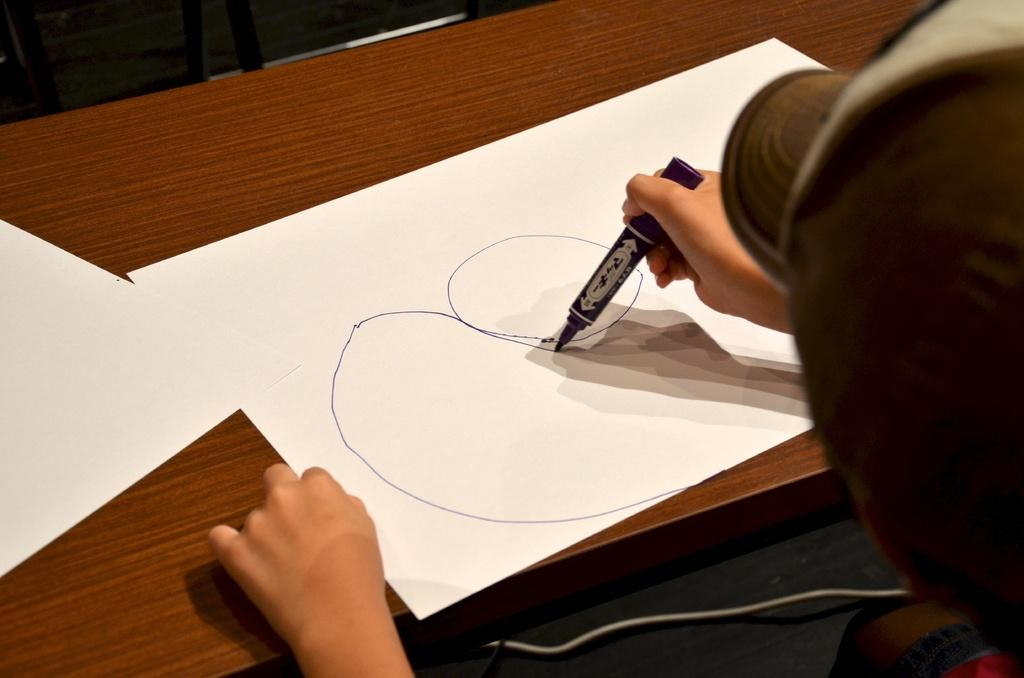What is present on the table in the image? There is a paper on the table. What is the person doing in the image? A person is drawing on the paper. Can you describe the table in the image? The table is a flat surface where the paper is placed. What scent can be detected from the drawing in the image? There is no information about the scent of the drawing in the image. The focus is on the visual aspects of the drawing and the table. 